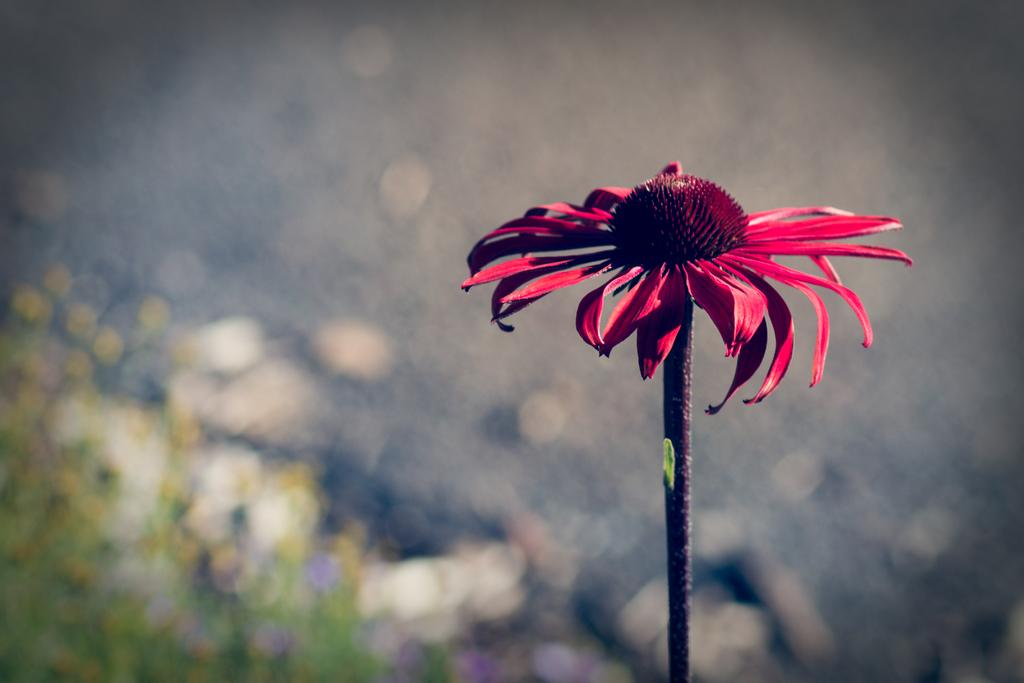What type of flower is in the picture? There is a red flower in the picture. What color are the petals of the flower? The flower has red petals. Does the flower have any other visible parts besides the petals? Yes, the flower has a stem. How would you describe the background of the image? The backdrop of the image is blurred. What type of pancake is being drawn on the chalkboard in the image? There is no chalkboard or pancake present in the image; it features a red flower with a blurred background. 